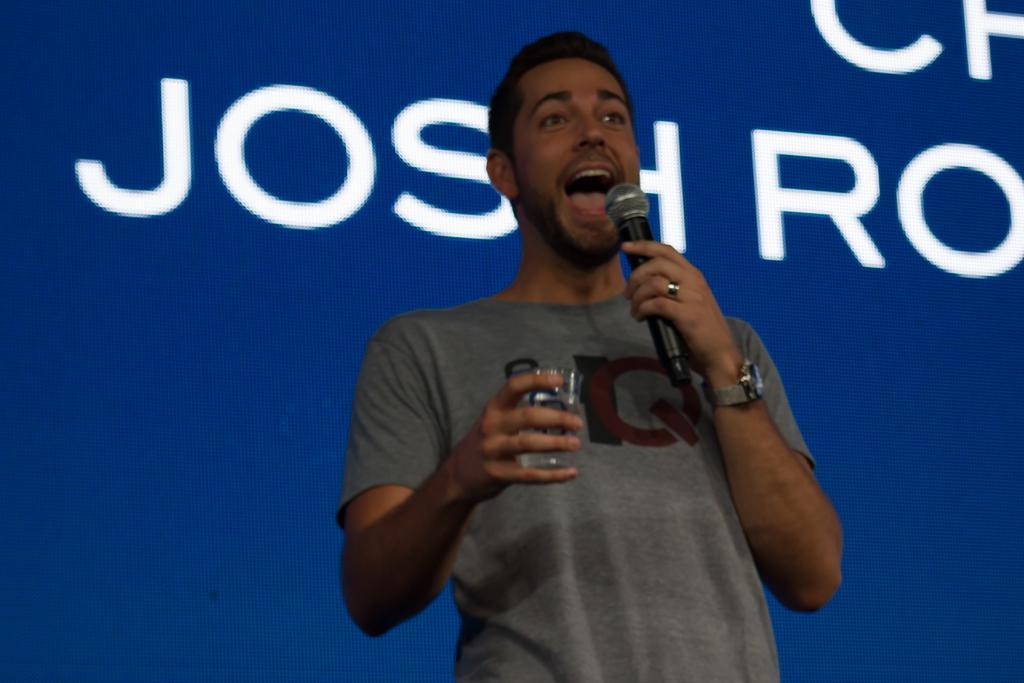Describe this image in one or two sentences. A man is speaking holding a mic in one hand and glass in another. 